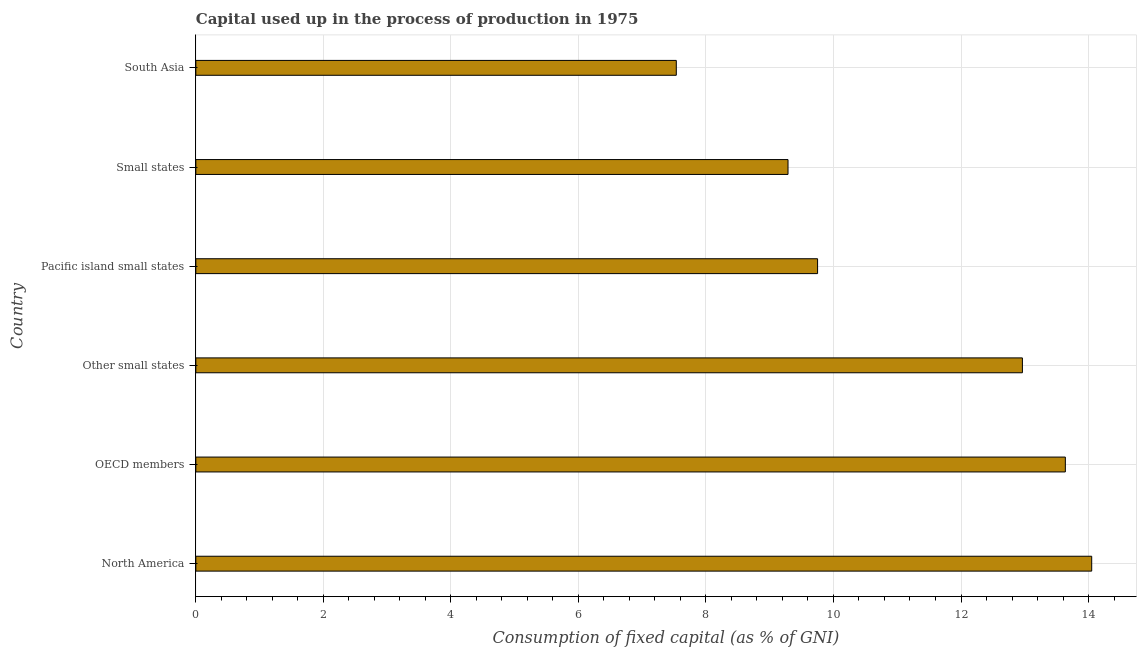What is the title of the graph?
Provide a short and direct response. Capital used up in the process of production in 1975. What is the label or title of the X-axis?
Your response must be concise. Consumption of fixed capital (as % of GNI). What is the label or title of the Y-axis?
Offer a terse response. Country. What is the consumption of fixed capital in Other small states?
Ensure brevity in your answer.  12.96. Across all countries, what is the maximum consumption of fixed capital?
Keep it short and to the point. 14.05. Across all countries, what is the minimum consumption of fixed capital?
Keep it short and to the point. 7.54. In which country was the consumption of fixed capital maximum?
Your answer should be compact. North America. In which country was the consumption of fixed capital minimum?
Provide a short and direct response. South Asia. What is the sum of the consumption of fixed capital?
Your answer should be compact. 67.22. What is the difference between the consumption of fixed capital in OECD members and South Asia?
Make the answer very short. 6.1. What is the average consumption of fixed capital per country?
Give a very brief answer. 11.2. What is the median consumption of fixed capital?
Provide a short and direct response. 11.36. In how many countries, is the consumption of fixed capital greater than 13.6 %?
Give a very brief answer. 2. What is the ratio of the consumption of fixed capital in Other small states to that in Small states?
Make the answer very short. 1.4. What is the difference between the highest and the second highest consumption of fixed capital?
Ensure brevity in your answer.  0.41. Is the sum of the consumption of fixed capital in North America and Pacific island small states greater than the maximum consumption of fixed capital across all countries?
Your answer should be very brief. Yes. What is the difference between the highest and the lowest consumption of fixed capital?
Your response must be concise. 6.51. Are all the bars in the graph horizontal?
Your answer should be very brief. Yes. What is the difference between two consecutive major ticks on the X-axis?
Ensure brevity in your answer.  2. Are the values on the major ticks of X-axis written in scientific E-notation?
Ensure brevity in your answer.  No. What is the Consumption of fixed capital (as % of GNI) of North America?
Provide a succinct answer. 14.05. What is the Consumption of fixed capital (as % of GNI) in OECD members?
Keep it short and to the point. 13.64. What is the Consumption of fixed capital (as % of GNI) of Other small states?
Offer a terse response. 12.96. What is the Consumption of fixed capital (as % of GNI) in Pacific island small states?
Your response must be concise. 9.75. What is the Consumption of fixed capital (as % of GNI) of Small states?
Offer a very short reply. 9.29. What is the Consumption of fixed capital (as % of GNI) of South Asia?
Ensure brevity in your answer.  7.54. What is the difference between the Consumption of fixed capital (as % of GNI) in North America and OECD members?
Keep it short and to the point. 0.41. What is the difference between the Consumption of fixed capital (as % of GNI) in North America and Other small states?
Ensure brevity in your answer.  1.09. What is the difference between the Consumption of fixed capital (as % of GNI) in North America and Pacific island small states?
Your response must be concise. 4.3. What is the difference between the Consumption of fixed capital (as % of GNI) in North America and Small states?
Your answer should be very brief. 4.76. What is the difference between the Consumption of fixed capital (as % of GNI) in North America and South Asia?
Provide a succinct answer. 6.51. What is the difference between the Consumption of fixed capital (as % of GNI) in OECD members and Other small states?
Ensure brevity in your answer.  0.67. What is the difference between the Consumption of fixed capital (as % of GNI) in OECD members and Pacific island small states?
Ensure brevity in your answer.  3.89. What is the difference between the Consumption of fixed capital (as % of GNI) in OECD members and Small states?
Your answer should be compact. 4.35. What is the difference between the Consumption of fixed capital (as % of GNI) in OECD members and South Asia?
Offer a very short reply. 6.1. What is the difference between the Consumption of fixed capital (as % of GNI) in Other small states and Pacific island small states?
Provide a succinct answer. 3.21. What is the difference between the Consumption of fixed capital (as % of GNI) in Other small states and Small states?
Offer a terse response. 3.68. What is the difference between the Consumption of fixed capital (as % of GNI) in Other small states and South Asia?
Your answer should be very brief. 5.43. What is the difference between the Consumption of fixed capital (as % of GNI) in Pacific island small states and Small states?
Ensure brevity in your answer.  0.46. What is the difference between the Consumption of fixed capital (as % of GNI) in Pacific island small states and South Asia?
Offer a terse response. 2.22. What is the difference between the Consumption of fixed capital (as % of GNI) in Small states and South Asia?
Offer a terse response. 1.75. What is the ratio of the Consumption of fixed capital (as % of GNI) in North America to that in OECD members?
Your answer should be very brief. 1.03. What is the ratio of the Consumption of fixed capital (as % of GNI) in North America to that in Other small states?
Provide a short and direct response. 1.08. What is the ratio of the Consumption of fixed capital (as % of GNI) in North America to that in Pacific island small states?
Provide a succinct answer. 1.44. What is the ratio of the Consumption of fixed capital (as % of GNI) in North America to that in Small states?
Keep it short and to the point. 1.51. What is the ratio of the Consumption of fixed capital (as % of GNI) in North America to that in South Asia?
Your response must be concise. 1.86. What is the ratio of the Consumption of fixed capital (as % of GNI) in OECD members to that in Other small states?
Provide a succinct answer. 1.05. What is the ratio of the Consumption of fixed capital (as % of GNI) in OECD members to that in Pacific island small states?
Your answer should be very brief. 1.4. What is the ratio of the Consumption of fixed capital (as % of GNI) in OECD members to that in Small states?
Make the answer very short. 1.47. What is the ratio of the Consumption of fixed capital (as % of GNI) in OECD members to that in South Asia?
Your response must be concise. 1.81. What is the ratio of the Consumption of fixed capital (as % of GNI) in Other small states to that in Pacific island small states?
Your response must be concise. 1.33. What is the ratio of the Consumption of fixed capital (as % of GNI) in Other small states to that in Small states?
Your answer should be compact. 1.4. What is the ratio of the Consumption of fixed capital (as % of GNI) in Other small states to that in South Asia?
Ensure brevity in your answer.  1.72. What is the ratio of the Consumption of fixed capital (as % of GNI) in Pacific island small states to that in South Asia?
Your answer should be very brief. 1.29. What is the ratio of the Consumption of fixed capital (as % of GNI) in Small states to that in South Asia?
Make the answer very short. 1.23. 